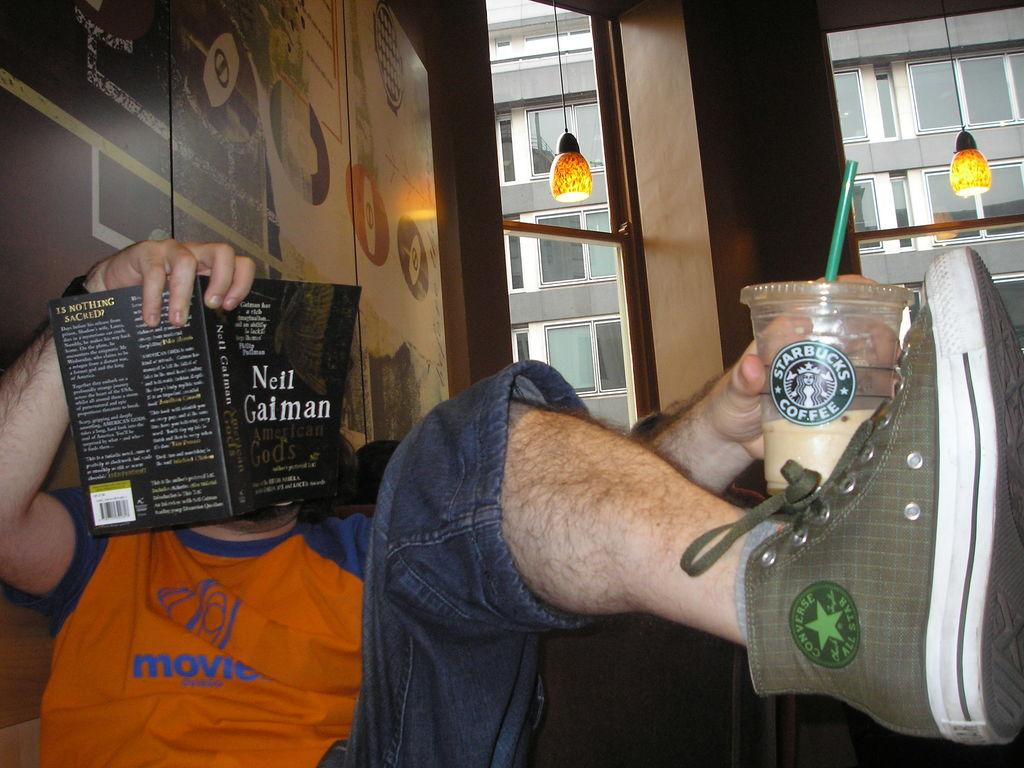<image>
Provide a brief description of the given image. a boy reading a book by nell gaiman and drinking starbucks coffee 